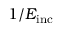Convert formula to latex. <formula><loc_0><loc_0><loc_500><loc_500>1 / E _ { i n c }</formula> 